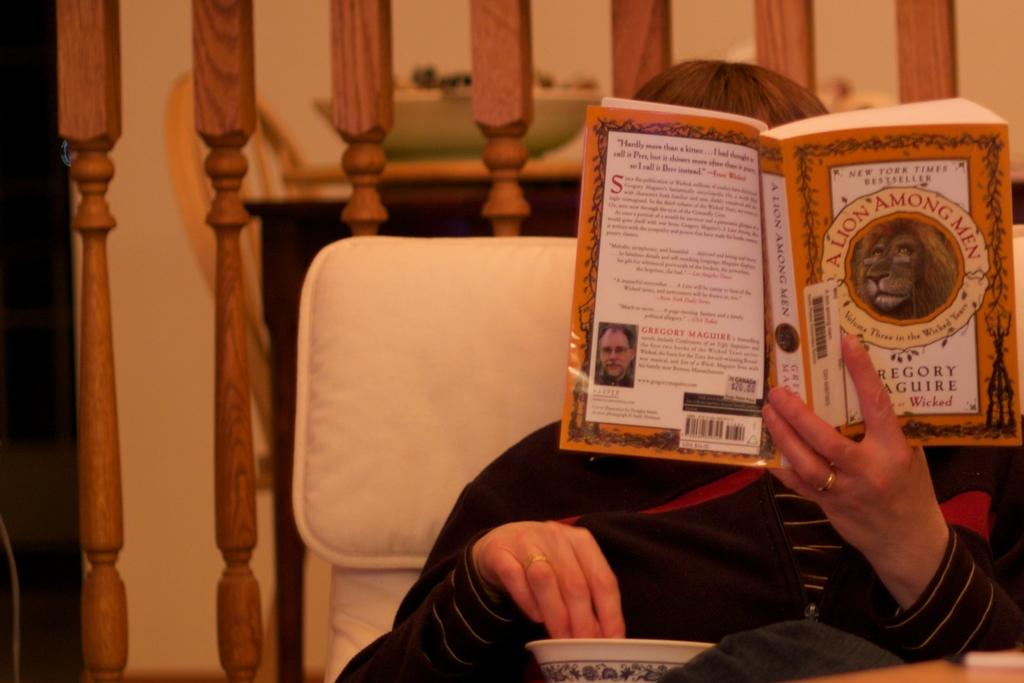Provide a one-sentence caption for the provided image. The young boy reads the novel "A Lion Among Men" as he enjoys his popcorn. 